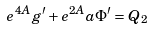<formula> <loc_0><loc_0><loc_500><loc_500>e ^ { 4 A } g ^ { \prime } + e ^ { 2 A } a \Phi ^ { \prime } = Q _ { 2 }</formula> 